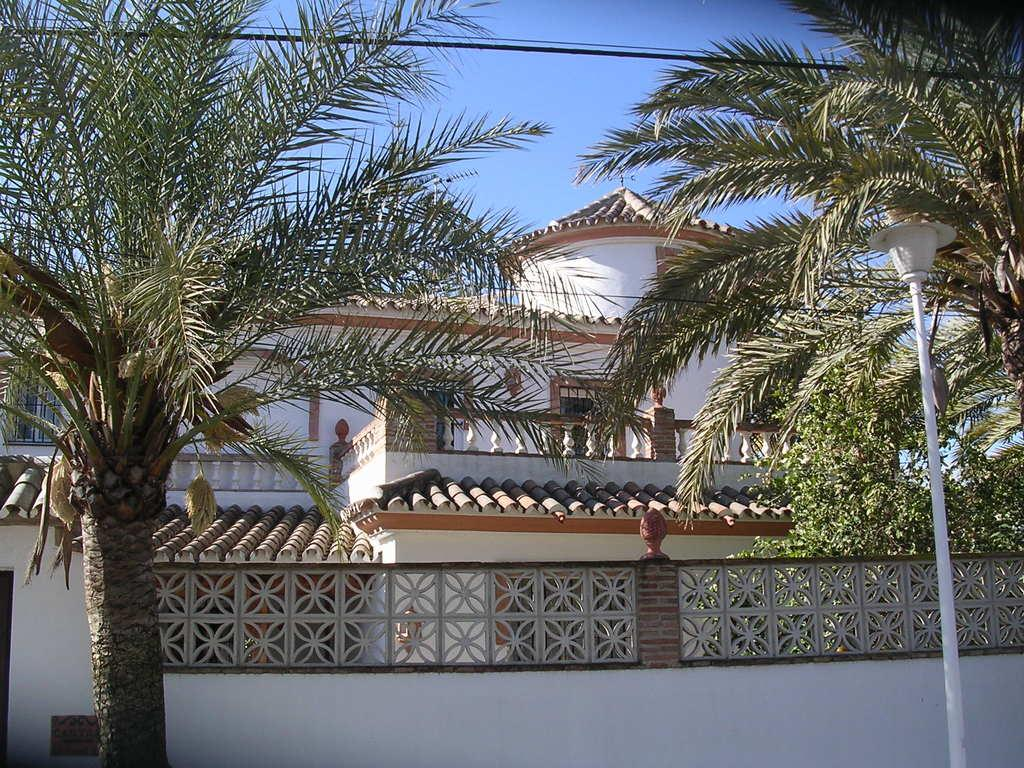What type of vegetation is present in the image? There are trees in the image. What object can be seen on the right side of the image? There is a pole on the right side of the image. What structure is visible in the background of the image? There is a building in the background of the image. What is visible at the top of the image? Wires and the sky are visible at the top of the image. Where is the quiver of arrows located in the image? There is no quiver of arrows present in the image. What type of books can be found in the library depicted in the image? There is no library present in the image. 